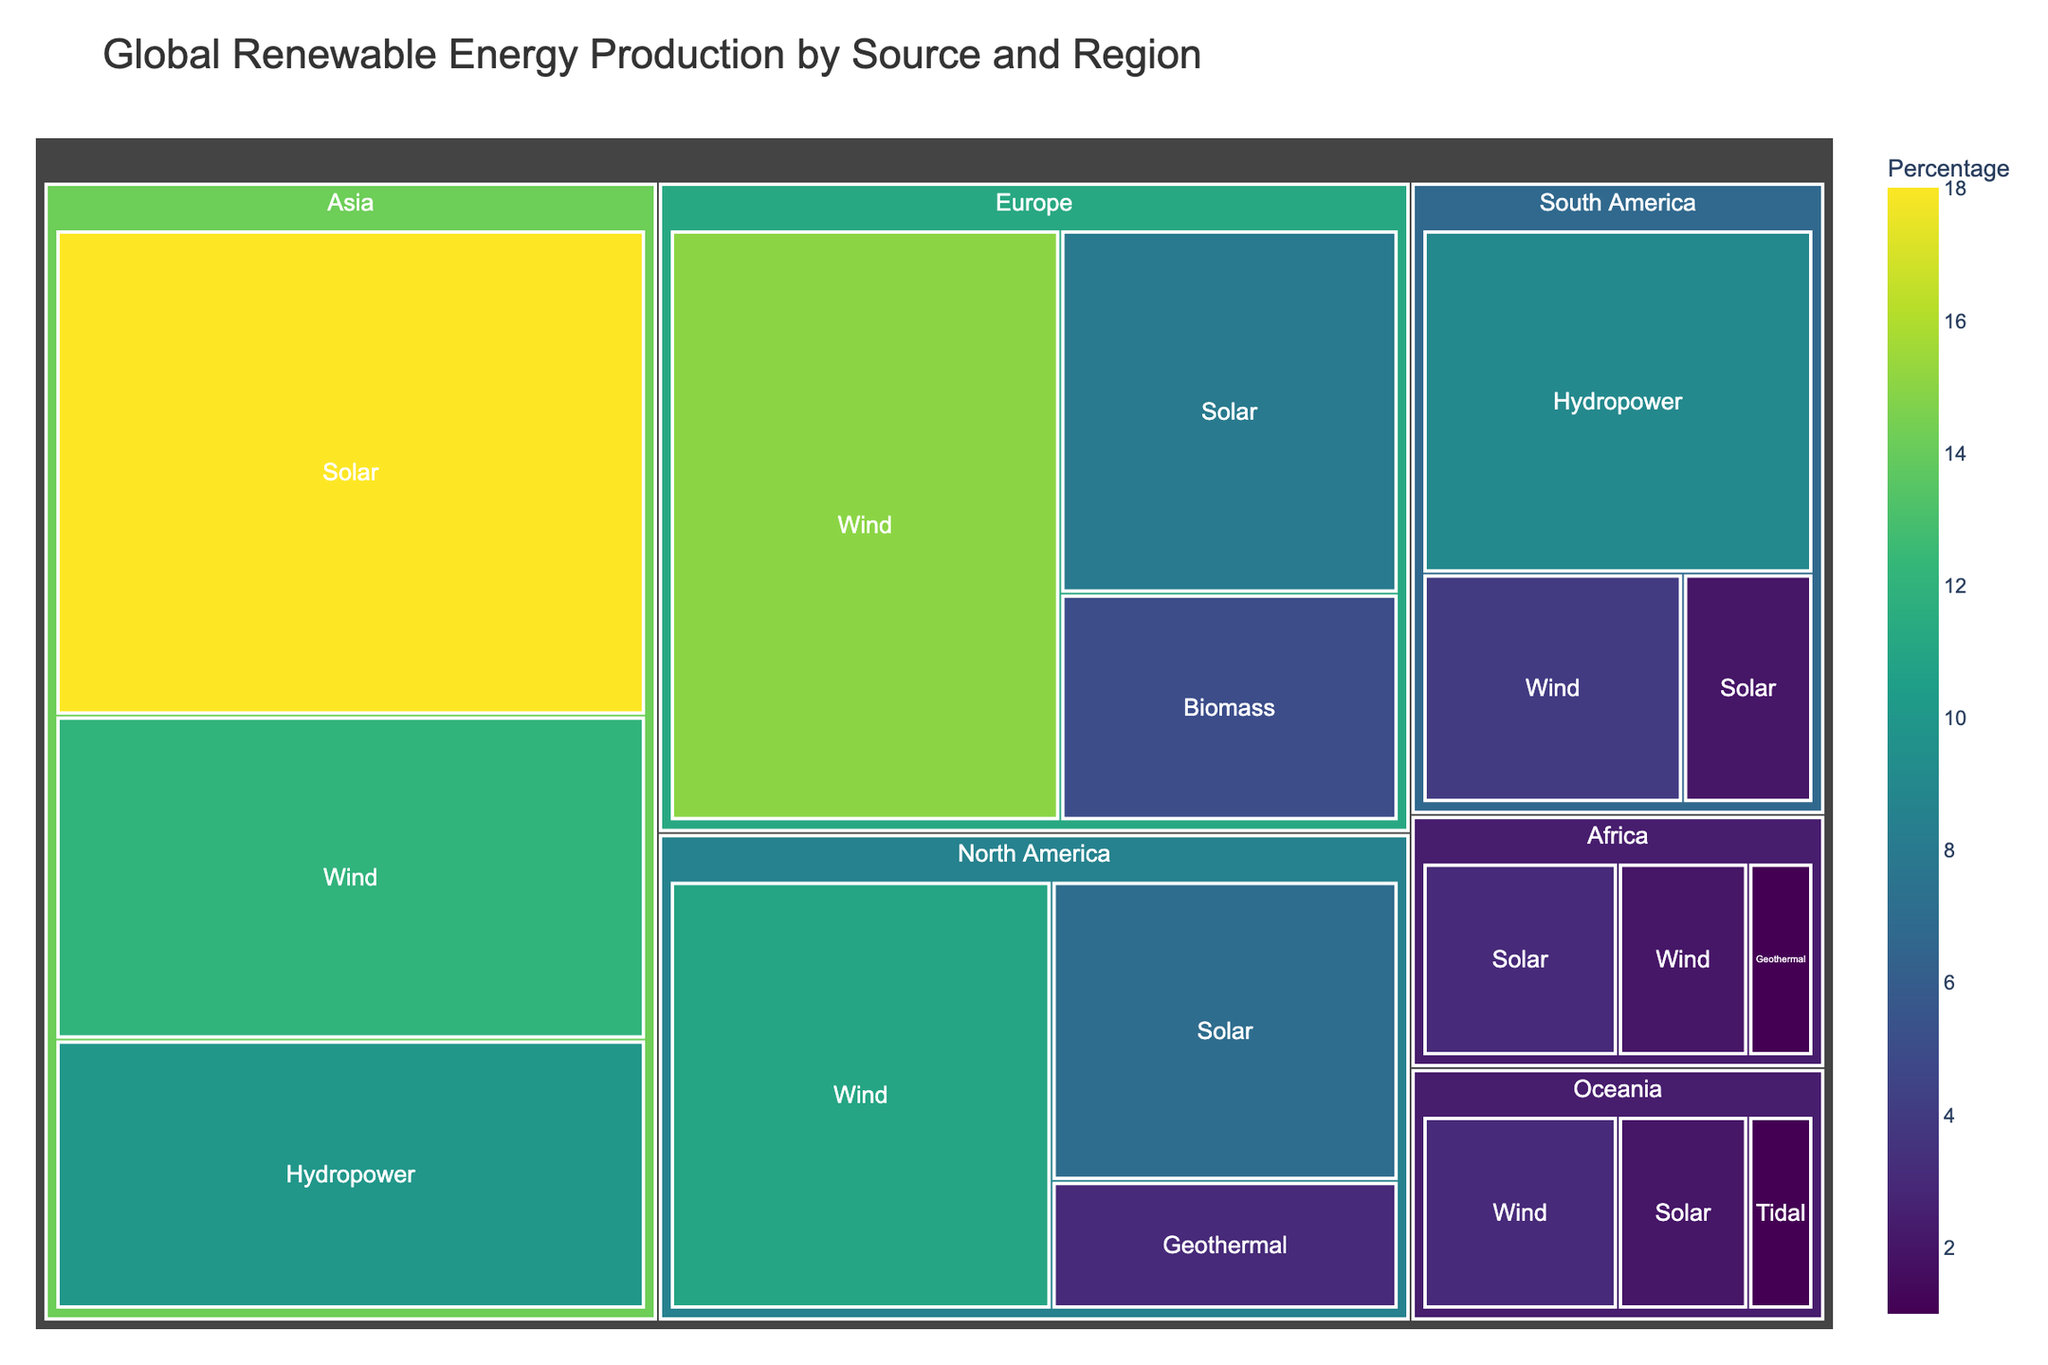what is the title of the treemap? The title is typically displayed at the top center of the figure. It gives a brief description of what the treemap represents. In this case, it is "Global Renewable Energy Production by Source and Region".
Answer: Global Renewable Energy Production by Source and Region Which region has the highest percentage of wind energy production? By examining the color intensity and the size of the segments labeled with 'Wind', Europe has the largest wind energy production at 15%.
Answer: Europe Which type of renewable energy is produced the most in North America? By looking at the segments under North America, the largest segment is for Wind, which has a percentage of 11%.
Answer: Wind List the regions where Geothermal energy is produced. From the figure, we can see Geothermal segments in North America and Africa.
Answer: North America and Africa What is the combined percentage of solar and wind energy production in Asia? To find the combined percentage, sum the percentage of solar energy (18%) and wind energy (12%) in Asia. 18 + 12 = 30%.
Answer: 30% Which source of renewable energy has the lowest percentage in the treemap? By identifying the smallest and least intense segment, Tidal energy in Oceania has the lowest percentage at 1%.
Answer: Tidal Compare the total percentage of renewable energy production in Asia and Europe. Which one is greater? Sum the individual percentages for each region. Asia: 18 + 12 + 10 = 40%, Europe: 15 + 8 + 5 = 28%. Asia has a greater total percentage.
Answer: Asia What is the average percentage of solar energy production across all regions? Sum the percentages of solar energy in all regions (18 + 8 + 7 + 2 + 3 + 2) and divide by the number of regions (6). (18+8+7+2+3+2)/6 = 6.67%.
Answer: 6.67% Identify the region and source combination for the segment with the second lowest energy production percentage. By looking at the segments with the lowest percentages, after Oceania's Tidal (1%), Africa's Geothermal also has 1%. Consider regions and sources for verifying.
Answer: Africa, Geothermal How does hydropower production in South America compare to that in Asia? Examine the segments for Hydropower in South America and Asia. South America has 9%, whereas Asia has 10%. Asia's hydropower production is slightly higher.
Answer: Asia 